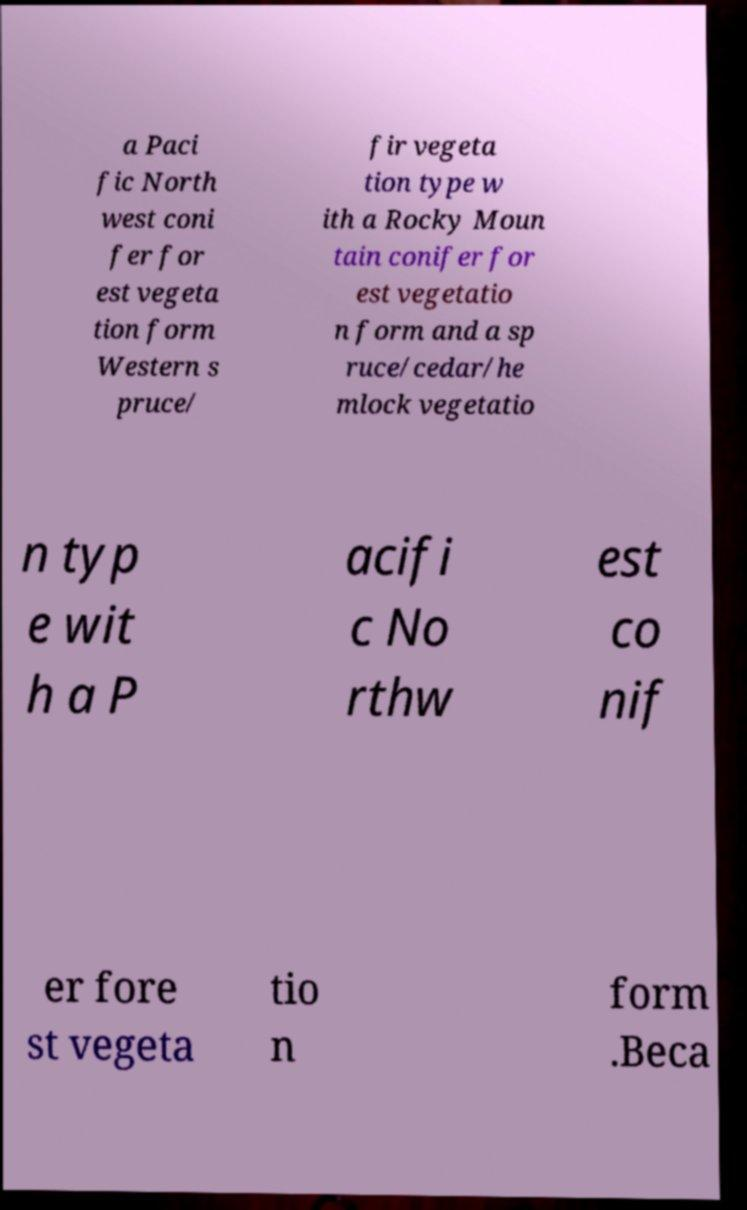What messages or text are displayed in this image? I need them in a readable, typed format. a Paci fic North west coni fer for est vegeta tion form Western s pruce/ fir vegeta tion type w ith a Rocky Moun tain conifer for est vegetatio n form and a sp ruce/cedar/he mlock vegetatio n typ e wit h a P acifi c No rthw est co nif er fore st vegeta tio n form .Beca 